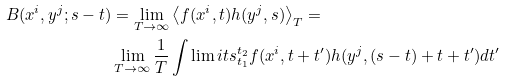Convert formula to latex. <formula><loc_0><loc_0><loc_500><loc_500>B ( x ^ { i } , y ^ { j } ; s - t ) & = \lim _ { T \rightarrow \infty } \left \langle f ( x ^ { i } , t ) h ( y ^ { j } , s ) \right \rangle _ { T } = \\ & \lim _ { T \rightarrow \infty } \frac { 1 } { T } \int \lim i t s _ { t _ { 1 } } ^ { t _ { 2 } } f ( x ^ { i } , t + t ^ { \prime } ) h ( y ^ { j } , ( s - t ) + t + t ^ { \prime } ) d t ^ { \prime }</formula> 